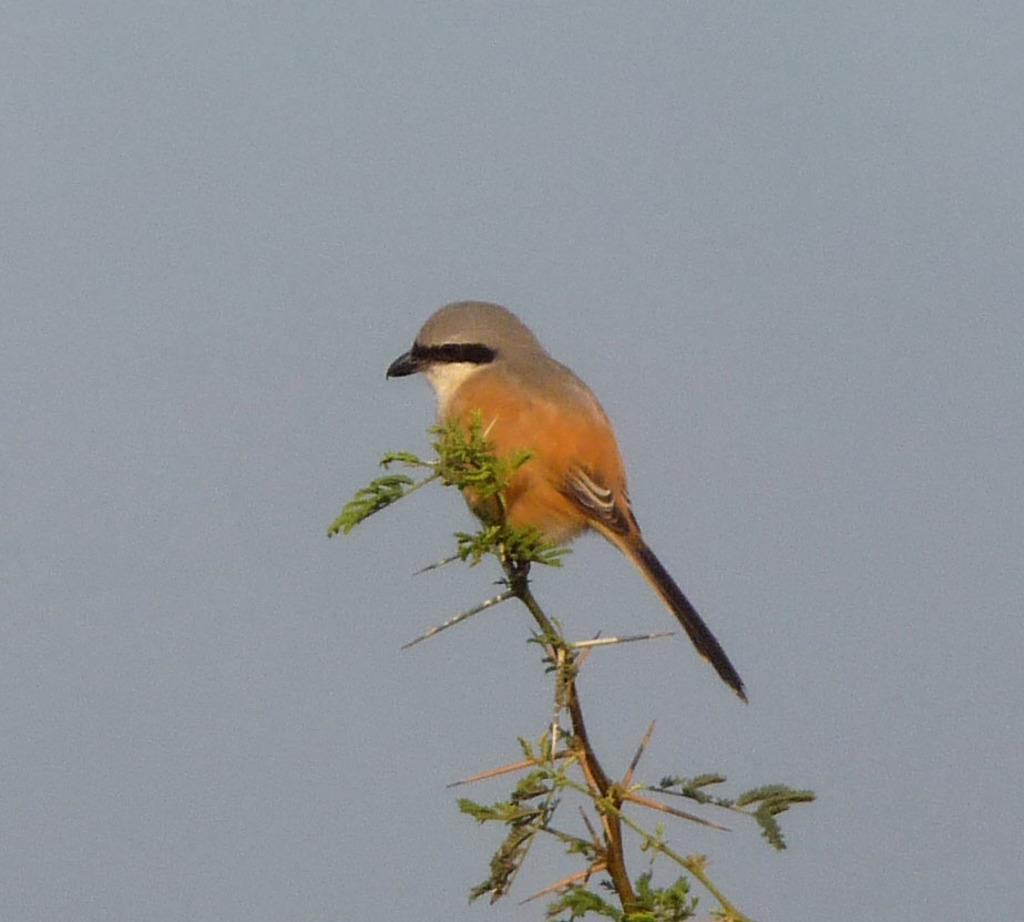What type of animal can be seen in the image? There is a bird in the image. Where is the bird located in the image? The bird is on the branch of a tree. What can be seen in the background of the image? There are leaves visible in the image. What type of fuel is the bird using to fly in the image? The bird does not appear to be flying in the image, and therefore it is not using any fuel. How many people are present in the image? There are no people present in the image; it features a bird on a tree branch. 